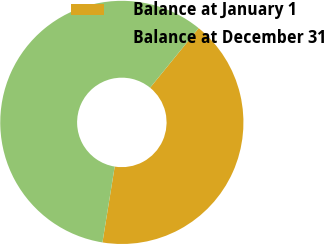Convert chart to OTSL. <chart><loc_0><loc_0><loc_500><loc_500><pie_chart><fcel>Balance at January 1<fcel>Balance at December 31<nl><fcel>41.67%<fcel>58.33%<nl></chart> 